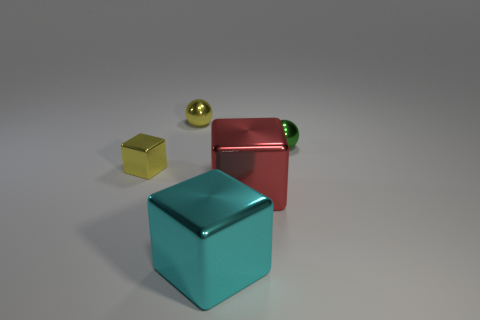Add 5 brown matte balls. How many objects exist? 10 Subtract all tiny rubber balls. Subtract all big cyan metal things. How many objects are left? 4 Add 4 cyan cubes. How many cyan cubes are left? 5 Add 4 small brown metal things. How many small brown metal things exist? 4 Subtract 0 gray balls. How many objects are left? 5 Subtract all blocks. How many objects are left? 2 